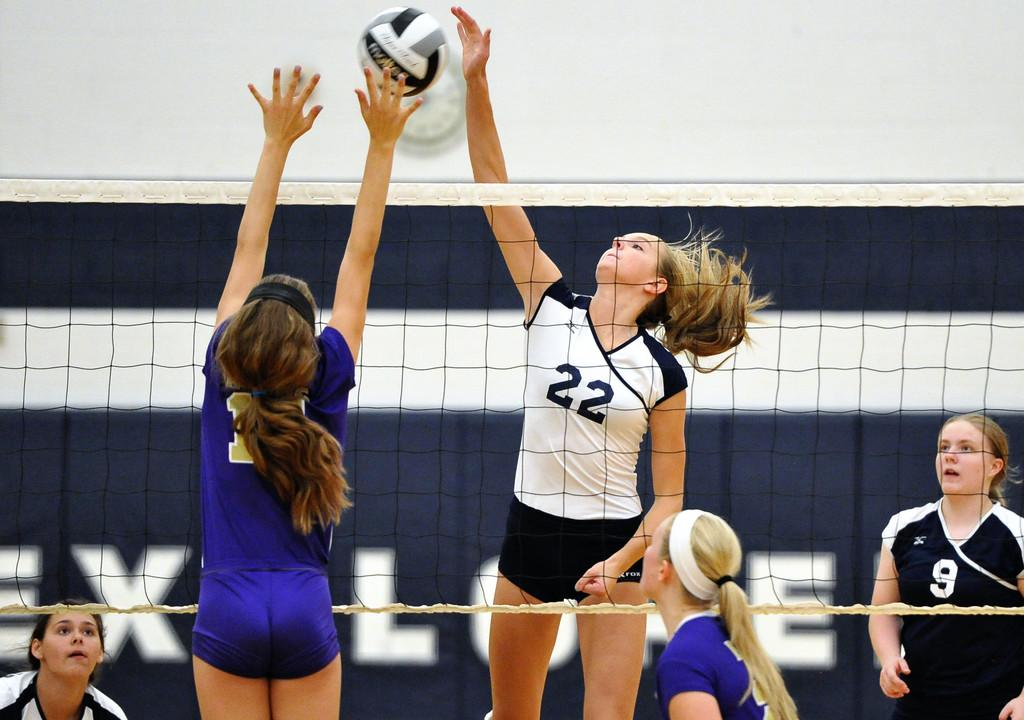<image>
Present a compact description of the photo's key features. Volleyball player wearing number 22 about to spike a ball. 